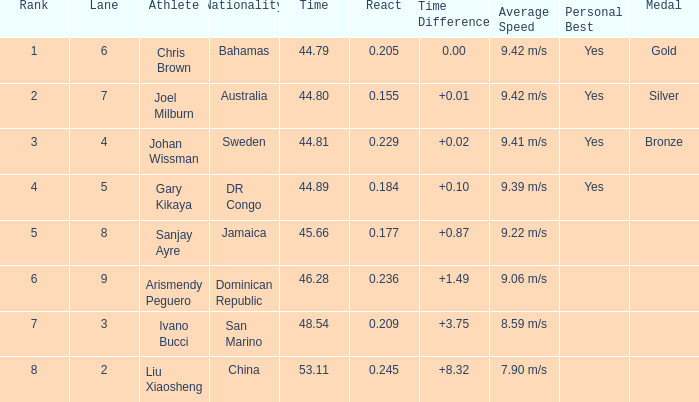What is the combined mean for rank entries where the lane stated is under 4 and the nationality recorded is san marino? 7.0. 